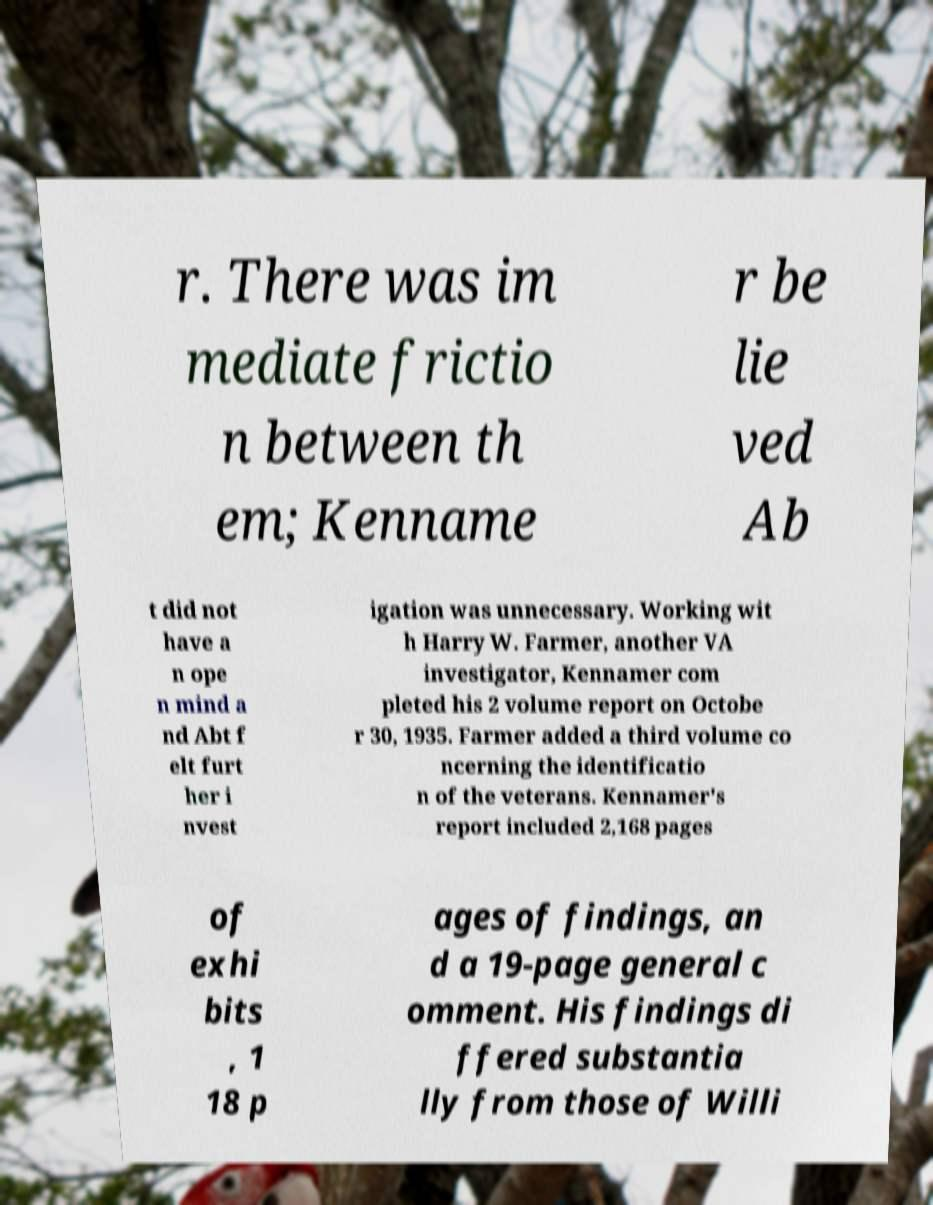Could you assist in decoding the text presented in this image and type it out clearly? r. There was im mediate frictio n between th em; Kenname r be lie ved Ab t did not have a n ope n mind a nd Abt f elt furt her i nvest igation was unnecessary. Working wit h Harry W. Farmer, another VA investigator, Kennamer com pleted his 2 volume report on Octobe r 30, 1935. Farmer added a third volume co ncerning the identificatio n of the veterans. Kennamer's report included 2,168 pages of exhi bits , 1 18 p ages of findings, an d a 19-page general c omment. His findings di ffered substantia lly from those of Willi 